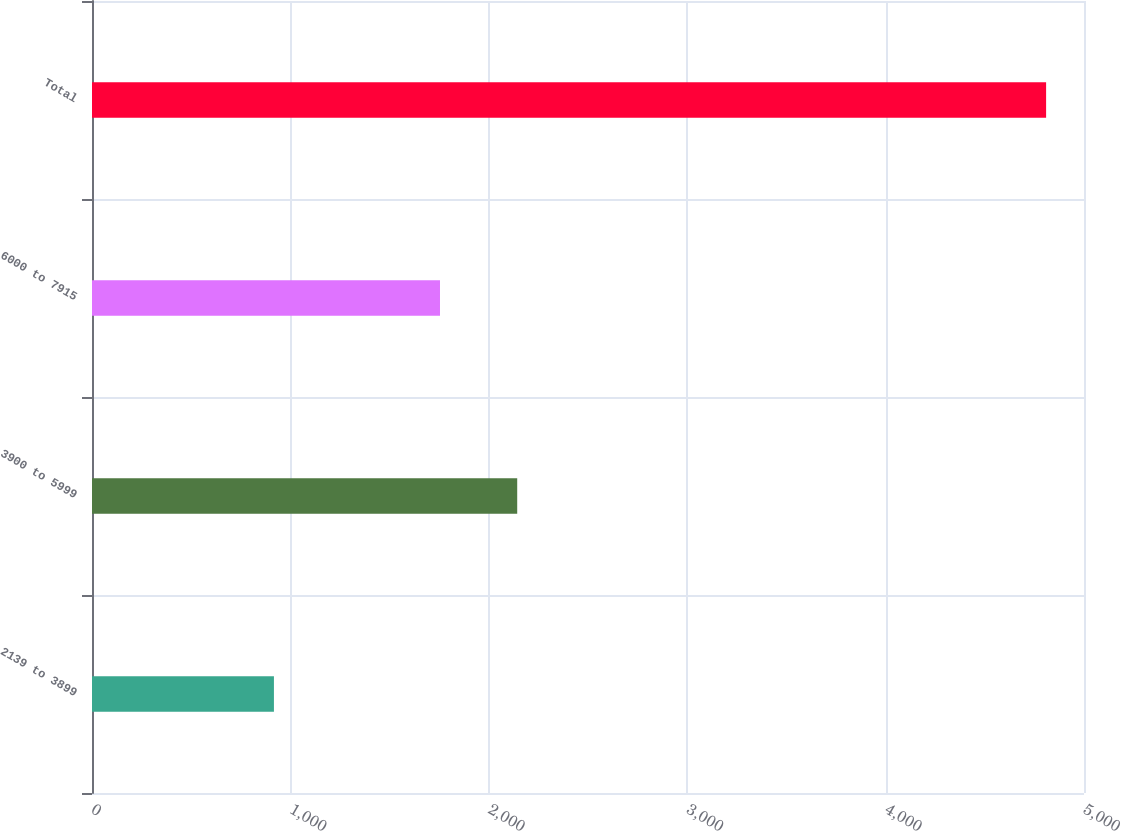Convert chart. <chart><loc_0><loc_0><loc_500><loc_500><bar_chart><fcel>2139 to 3899<fcel>3900 to 5999<fcel>6000 to 7915<fcel>Total<nl><fcel>917<fcel>2143.2<fcel>1754<fcel>4809<nl></chart> 